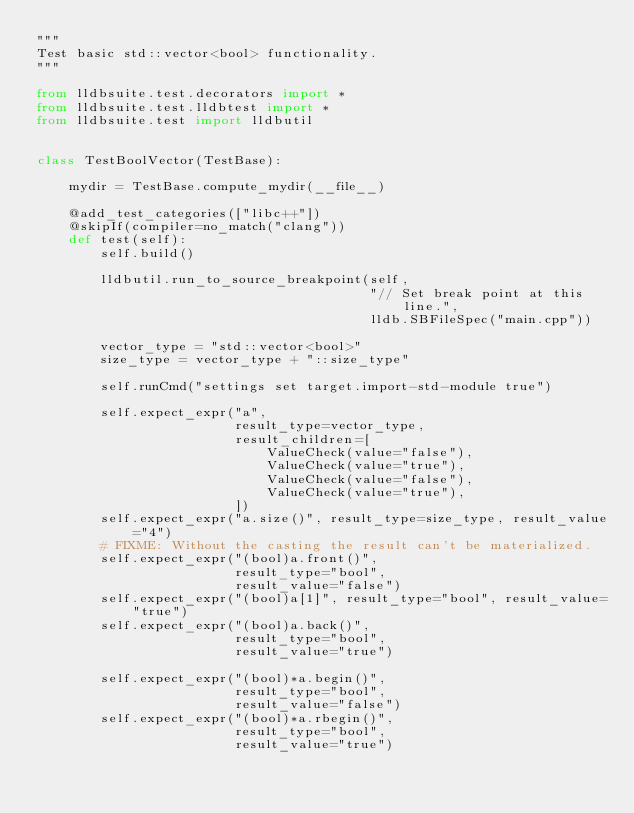Convert code to text. <code><loc_0><loc_0><loc_500><loc_500><_Python_>"""
Test basic std::vector<bool> functionality.
"""

from lldbsuite.test.decorators import *
from lldbsuite.test.lldbtest import *
from lldbsuite.test import lldbutil


class TestBoolVector(TestBase):

    mydir = TestBase.compute_mydir(__file__)

    @add_test_categories(["libc++"])
    @skipIf(compiler=no_match("clang"))
    def test(self):
        self.build()

        lldbutil.run_to_source_breakpoint(self,
                                          "// Set break point at this line.",
                                          lldb.SBFileSpec("main.cpp"))

        vector_type = "std::vector<bool>"
        size_type = vector_type + "::size_type"

        self.runCmd("settings set target.import-std-module true")

        self.expect_expr("a",
                         result_type=vector_type,
                         result_children=[
                             ValueCheck(value="false"),
                             ValueCheck(value="true"),
                             ValueCheck(value="false"),
                             ValueCheck(value="true"),
                         ])
        self.expect_expr("a.size()", result_type=size_type, result_value="4")
        # FIXME: Without the casting the result can't be materialized.
        self.expect_expr("(bool)a.front()",
                         result_type="bool",
                         result_value="false")
        self.expect_expr("(bool)a[1]", result_type="bool", result_value="true")
        self.expect_expr("(bool)a.back()",
                         result_type="bool",
                         result_value="true")

        self.expect_expr("(bool)*a.begin()",
                         result_type="bool",
                         result_value="false")
        self.expect_expr("(bool)*a.rbegin()",
                         result_type="bool",
                         result_value="true")
</code> 